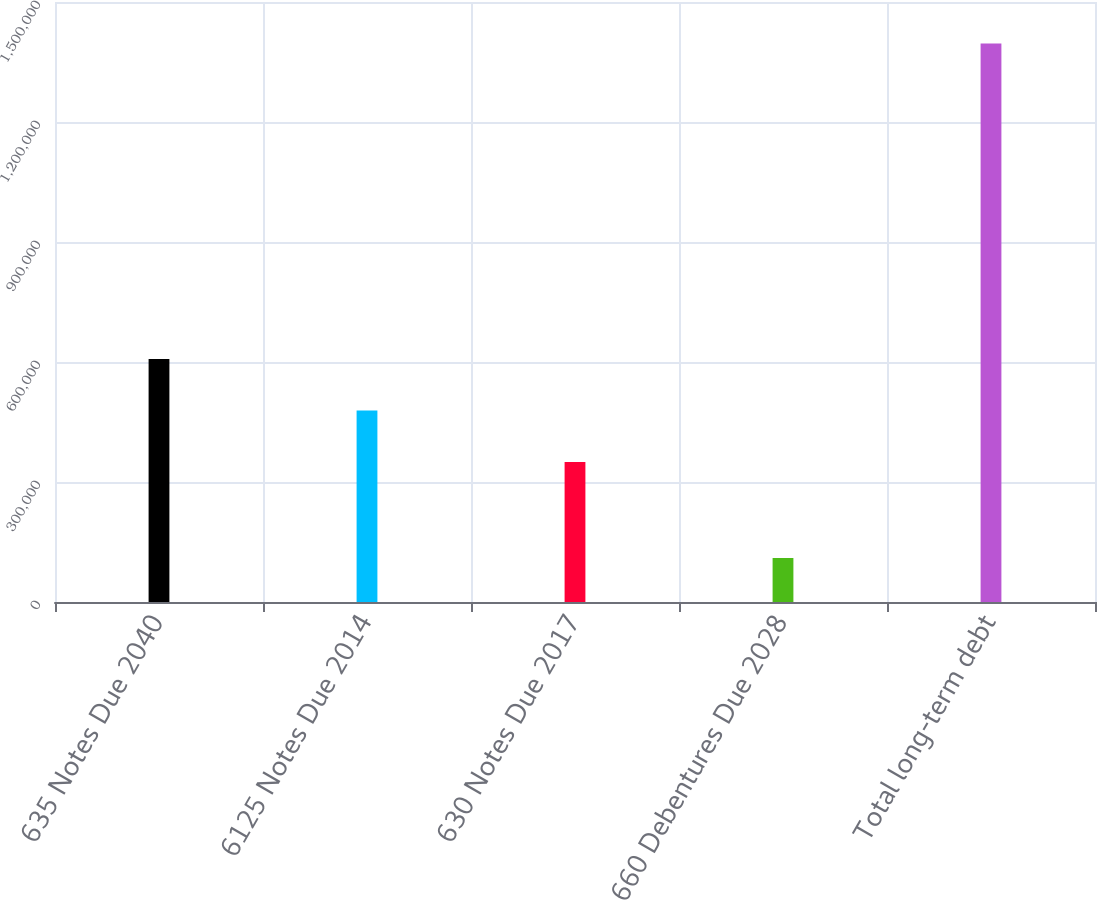<chart> <loc_0><loc_0><loc_500><loc_500><bar_chart><fcel>635 Notes Due 2040<fcel>6125 Notes Due 2014<fcel>630 Notes Due 2017<fcel>660 Debentures Due 2028<fcel>Total long-term debt<nl><fcel>607305<fcel>478653<fcel>350000<fcel>109895<fcel>1.39642e+06<nl></chart> 